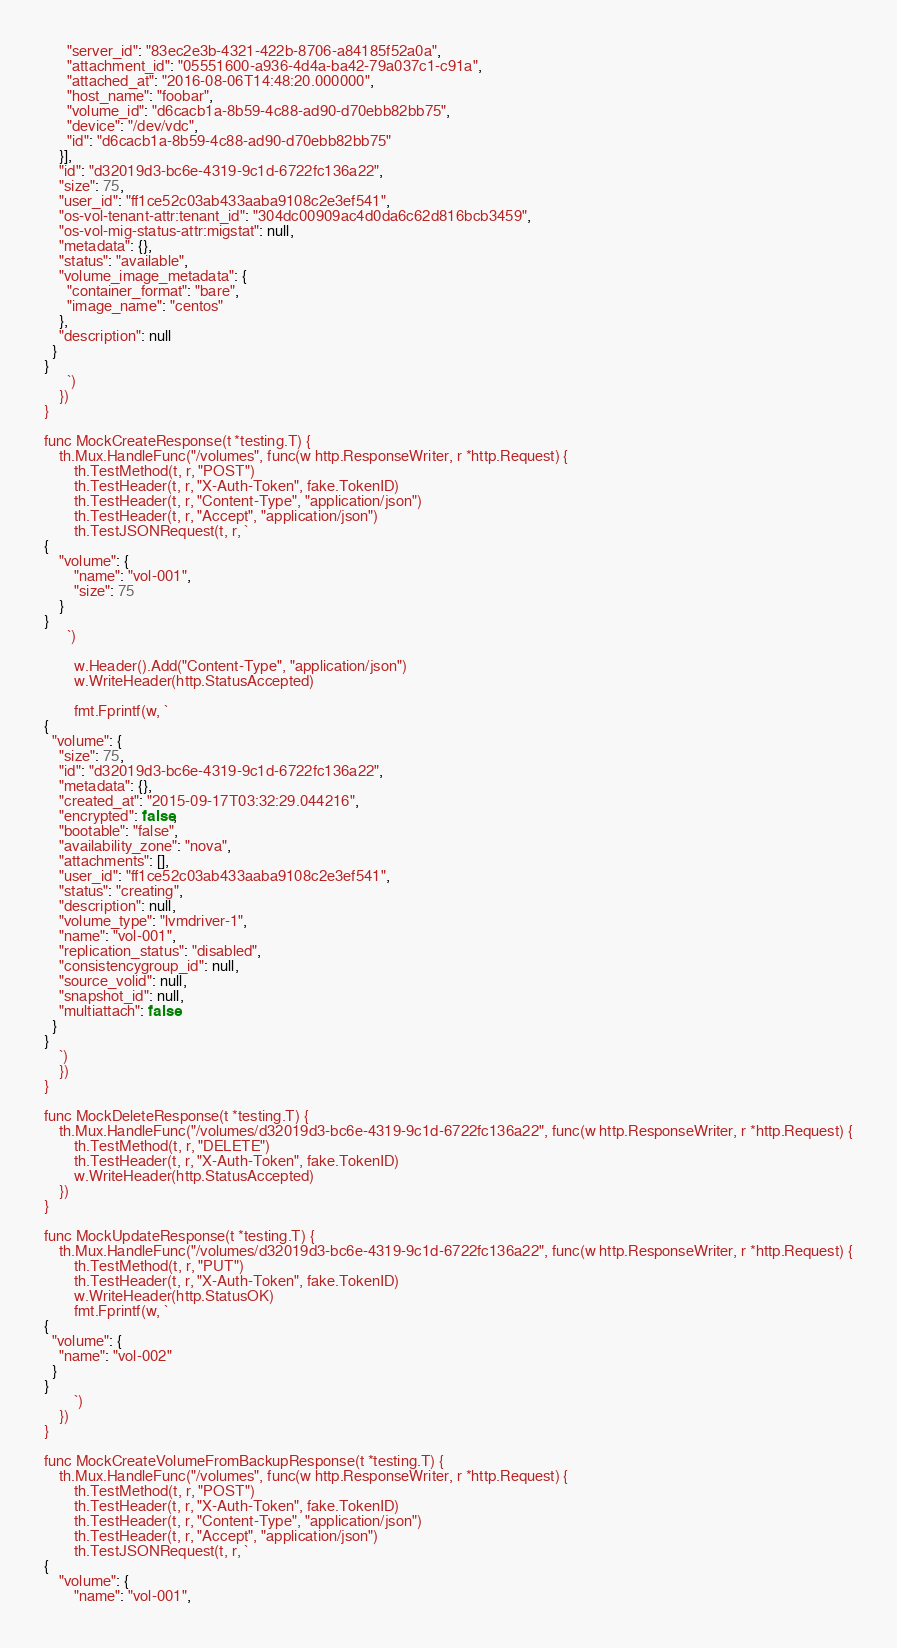Convert code to text. <code><loc_0><loc_0><loc_500><loc_500><_Go_>      "server_id": "83ec2e3b-4321-422b-8706-a84185f52a0a",
      "attachment_id": "05551600-a936-4d4a-ba42-79a037c1-c91a",
      "attached_at": "2016-08-06T14:48:20.000000",
      "host_name": "foobar",
      "volume_id": "d6cacb1a-8b59-4c88-ad90-d70ebb82bb75",
      "device": "/dev/vdc",
      "id": "d6cacb1a-8b59-4c88-ad90-d70ebb82bb75"
    }],
    "id": "d32019d3-bc6e-4319-9c1d-6722fc136a22",
    "size": 75,
    "user_id": "ff1ce52c03ab433aaba9108c2e3ef541",
    "os-vol-tenant-attr:tenant_id": "304dc00909ac4d0da6c62d816bcb3459",
    "os-vol-mig-status-attr:migstat": null,
    "metadata": {},
    "status": "available",
    "volume_image_metadata": {
      "container_format": "bare",
      "image_name": "centos"
    },
    "description": null
  }
}
      `)
	})
}

func MockCreateResponse(t *testing.T) {
	th.Mux.HandleFunc("/volumes", func(w http.ResponseWriter, r *http.Request) {
		th.TestMethod(t, r, "POST")
		th.TestHeader(t, r, "X-Auth-Token", fake.TokenID)
		th.TestHeader(t, r, "Content-Type", "application/json")
		th.TestHeader(t, r, "Accept", "application/json")
		th.TestJSONRequest(t, r, `
{
    "volume": {
    	"name": "vol-001",
        "size": 75
    }
}
      `)

		w.Header().Add("Content-Type", "application/json")
		w.WriteHeader(http.StatusAccepted)

		fmt.Fprintf(w, `
{
  "volume": {
    "size": 75,
    "id": "d32019d3-bc6e-4319-9c1d-6722fc136a22",
    "metadata": {},
    "created_at": "2015-09-17T03:32:29.044216",
    "encrypted": false,
    "bootable": "false",
    "availability_zone": "nova",
    "attachments": [],
    "user_id": "ff1ce52c03ab433aaba9108c2e3ef541",
    "status": "creating",
    "description": null,
    "volume_type": "lvmdriver-1",
    "name": "vol-001",
    "replication_status": "disabled",
    "consistencygroup_id": null,
    "source_volid": null,
    "snapshot_id": null,
    "multiattach": false
  }
}
    `)
	})
}

func MockDeleteResponse(t *testing.T) {
	th.Mux.HandleFunc("/volumes/d32019d3-bc6e-4319-9c1d-6722fc136a22", func(w http.ResponseWriter, r *http.Request) {
		th.TestMethod(t, r, "DELETE")
		th.TestHeader(t, r, "X-Auth-Token", fake.TokenID)
		w.WriteHeader(http.StatusAccepted)
	})
}

func MockUpdateResponse(t *testing.T) {
	th.Mux.HandleFunc("/volumes/d32019d3-bc6e-4319-9c1d-6722fc136a22", func(w http.ResponseWriter, r *http.Request) {
		th.TestMethod(t, r, "PUT")
		th.TestHeader(t, r, "X-Auth-Token", fake.TokenID)
		w.WriteHeader(http.StatusOK)
		fmt.Fprintf(w, `
{
  "volume": {
    "name": "vol-002"
  }
}
        `)
	})
}

func MockCreateVolumeFromBackupResponse(t *testing.T) {
	th.Mux.HandleFunc("/volumes", func(w http.ResponseWriter, r *http.Request) {
		th.TestMethod(t, r, "POST")
		th.TestHeader(t, r, "X-Auth-Token", fake.TokenID)
		th.TestHeader(t, r, "Content-Type", "application/json")
		th.TestHeader(t, r, "Accept", "application/json")
		th.TestJSONRequest(t, r, `
{
    "volume": {
        "name": "vol-001",</code> 